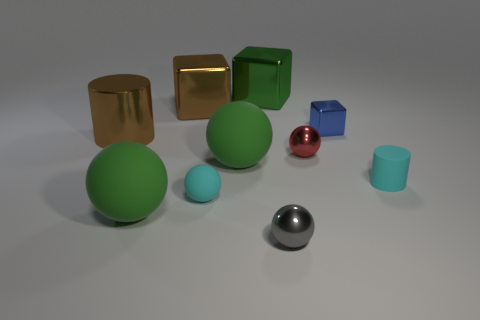Subtract all big cubes. How many cubes are left? 1 Subtract all cyan cubes. How many green balls are left? 2 Subtract all brown cubes. How many cubes are left? 2 Subtract 4 balls. How many balls are left? 1 Subtract all cylinders. How many objects are left? 8 Add 7 tiny cyan balls. How many tiny cyan balls are left? 8 Add 7 green spheres. How many green spheres exist? 9 Subtract 0 gray cubes. How many objects are left? 10 Subtract all green cylinders. Subtract all cyan spheres. How many cylinders are left? 2 Subtract all big green things. Subtract all big matte balls. How many objects are left? 5 